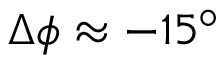Convert formula to latex. <formula><loc_0><loc_0><loc_500><loc_500>\Delta \phi \approx - 1 5 ^ { \circ }</formula> 